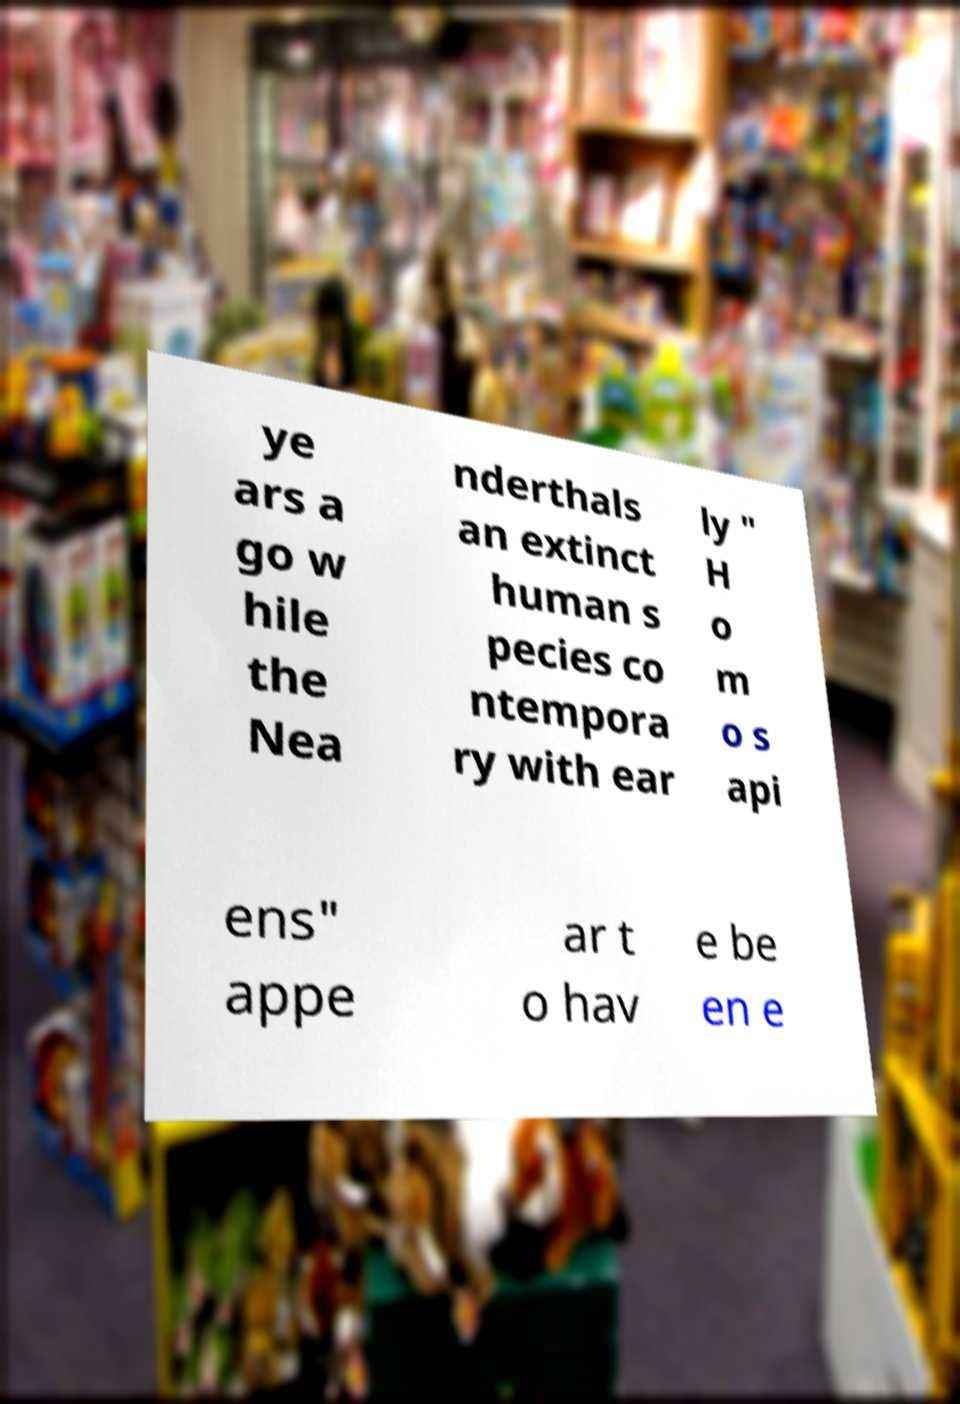What messages or text are displayed in this image? I need them in a readable, typed format. ye ars a go w hile the Nea nderthals an extinct human s pecies co ntempora ry with ear ly " H o m o s api ens" appe ar t o hav e be en e 